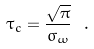Convert formula to latex. <formula><loc_0><loc_0><loc_500><loc_500>\tau _ { c } = \frac { \sqrt { \pi } } { \sigma _ { \omega } } \ .</formula> 